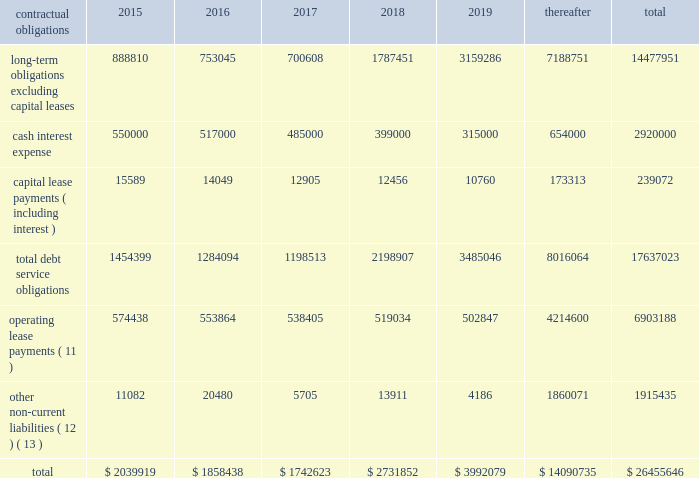
( 1 ) represents anticipated repayment date ; final legal maturity date is march 15 , 2043 .
( 2 ) represents anticipated repayment date ; final legal maturity date is march 15 , 2048 .
( 3 ) in connection with our acquisition of mipt on october 1 , 2013 , we assumed approximately $ 1.49 billion aggregate principal amount of secured notes , $ 250.0 million of which we repaid in august 2014 .
The gtp notes have anticipated repayment dates beginning june 15 , 2016 .
( 4 ) assumed in connection with our acquisition of br towers and denominated in brl .
The br towers debenture amortizes through october 2023 .
The br towers credit facility amortizes through january 15 , ( 5 ) assumed by us in connection with the unison acquisition , and have anticipated repayment dates of april 15 , 2017 , april 15 , 2020 and april 15 , 2020 , respectively , and a final maturity date of april 15 , 2040 .
( 6 ) denominated in mxn .
( 7 ) denominated in zar and amortizes through march 31 , 2020 .
( 8 ) denominated in cop and amortizes through april 24 , 2021 .
( 9 ) reflects balances owed to our joint venture partners in ghana and uganda .
The ghana loan is denominated in ghs and the uganda loan is denominated in usd .
( 10 ) on february 11 , 2015 , we redeemed all of the outstanding 4.625% ( 4.625 % ) notes in accordance with the terms thereof .
( 11 ) includes payments under non-cancellable initial terms , as well as payments for certain renewal periods at our option , which we expect to renew because failure to renew could result in a loss of the applicable communications sites and related revenues from tenant leases .
( 12 ) primarily represents our asset retirement obligations and excludes certain other non-current liabilities included in our consolidated balance sheet , primarily our straight-line rent liability for which cash payments are included in operating lease payments and unearned revenue that is not payable in cash .
( 13 ) excludes $ 26.6 million of liabilities for unrecognized tax positions and $ 24.9 million of accrued income tax related interest and penalties included in our consolidated balance sheet as we are uncertain as to when and if the amounts may be settled .
Settlement of such amounts could require the use of cash flows generated from operations .
We expect the unrecognized tax benefits to change over the next 12 months if certain tax matters ultimately settle with the applicable taxing jurisdiction during this timeframe .
However , based on the status of these items and the amount of uncertainty associated with the outcome and timing of audit settlements , we are currently unable to estimate the impact of the amount of such changes , if any , to previously recorded uncertain tax positions .
Off-balance sheet arrangements .
We have no material off-balance sheet arrangements as defined in item 303 ( a ) ( 4 ) ( ii ) of sec regulation s-k .
Interest rate swap agreements .
We have entered into interest rate swap agreements to manage our exposure to variability in interest rates on debt in colombia and south africa .
All of our interest rate swap agreements have been designated as cash flow hedges and have an aggregate notional amount of $ 79.9 million , interest rates ranging from 5.74% ( 5.74 % ) to 7.83% ( 7.83 % ) and expiration dates through april 2021 .
In february 2014 , we repaid the costa rica loan and subsequently terminated the associated interest rate swap agreements .
Additionally , in connection with entering into the colombian credit facility in october 2014 , we terminated our pre-existing interest rate .
What percentage of operating lease payments are due after 5 years? 
Computations: (4214600 / 6903188)
Answer: 0.61053. 